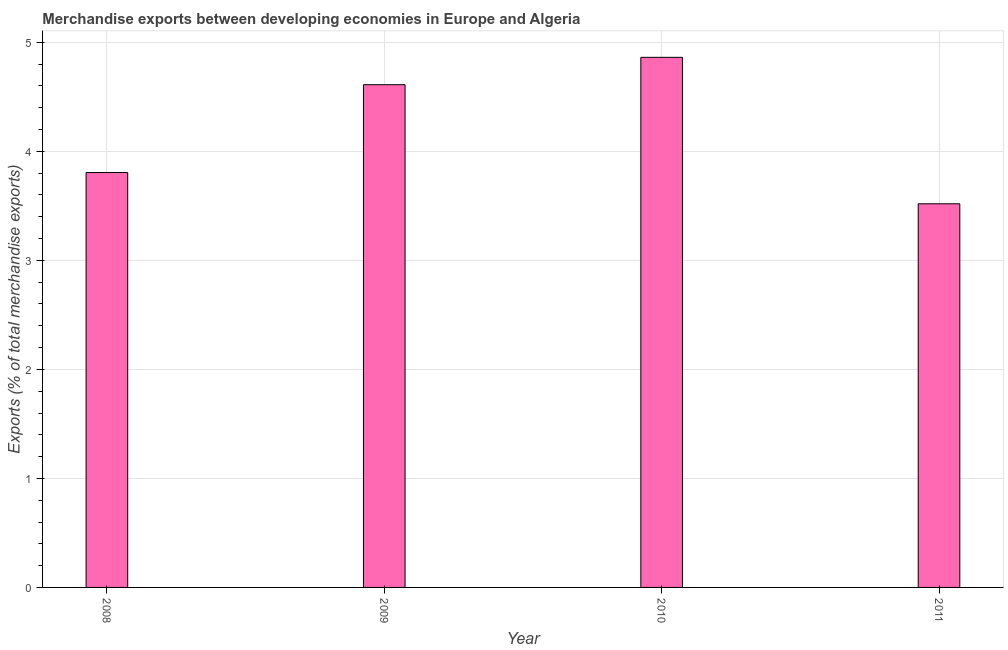What is the title of the graph?
Provide a short and direct response. Merchandise exports between developing economies in Europe and Algeria. What is the label or title of the X-axis?
Keep it short and to the point. Year. What is the label or title of the Y-axis?
Offer a terse response. Exports (% of total merchandise exports). What is the merchandise exports in 2011?
Your answer should be very brief. 3.52. Across all years, what is the maximum merchandise exports?
Offer a very short reply. 4.86. Across all years, what is the minimum merchandise exports?
Give a very brief answer. 3.52. In which year was the merchandise exports maximum?
Your answer should be compact. 2010. In which year was the merchandise exports minimum?
Your response must be concise. 2011. What is the sum of the merchandise exports?
Make the answer very short. 16.8. What is the difference between the merchandise exports in 2010 and 2011?
Offer a terse response. 1.34. What is the median merchandise exports?
Your answer should be very brief. 4.21. Do a majority of the years between 2008 and 2011 (inclusive) have merchandise exports greater than 0.6 %?
Give a very brief answer. Yes. What is the ratio of the merchandise exports in 2008 to that in 2009?
Ensure brevity in your answer.  0.82. Is the merchandise exports in 2008 less than that in 2011?
Offer a terse response. No. Is the difference between the merchandise exports in 2009 and 2011 greater than the difference between any two years?
Give a very brief answer. No. What is the difference between the highest and the second highest merchandise exports?
Your answer should be very brief. 0.25. What is the difference between the highest and the lowest merchandise exports?
Your response must be concise. 1.34. In how many years, is the merchandise exports greater than the average merchandise exports taken over all years?
Your answer should be very brief. 2. How many years are there in the graph?
Give a very brief answer. 4. What is the difference between two consecutive major ticks on the Y-axis?
Offer a terse response. 1. What is the Exports (% of total merchandise exports) in 2008?
Ensure brevity in your answer.  3.81. What is the Exports (% of total merchandise exports) of 2009?
Your response must be concise. 4.61. What is the Exports (% of total merchandise exports) of 2010?
Make the answer very short. 4.86. What is the Exports (% of total merchandise exports) in 2011?
Provide a succinct answer. 3.52. What is the difference between the Exports (% of total merchandise exports) in 2008 and 2009?
Offer a terse response. -0.81. What is the difference between the Exports (% of total merchandise exports) in 2008 and 2010?
Offer a very short reply. -1.06. What is the difference between the Exports (% of total merchandise exports) in 2008 and 2011?
Make the answer very short. 0.29. What is the difference between the Exports (% of total merchandise exports) in 2009 and 2010?
Give a very brief answer. -0.25. What is the difference between the Exports (% of total merchandise exports) in 2009 and 2011?
Your answer should be compact. 1.09. What is the difference between the Exports (% of total merchandise exports) in 2010 and 2011?
Provide a short and direct response. 1.34. What is the ratio of the Exports (% of total merchandise exports) in 2008 to that in 2009?
Ensure brevity in your answer.  0.82. What is the ratio of the Exports (% of total merchandise exports) in 2008 to that in 2010?
Make the answer very short. 0.78. What is the ratio of the Exports (% of total merchandise exports) in 2008 to that in 2011?
Keep it short and to the point. 1.08. What is the ratio of the Exports (% of total merchandise exports) in 2009 to that in 2010?
Make the answer very short. 0.95. What is the ratio of the Exports (% of total merchandise exports) in 2009 to that in 2011?
Keep it short and to the point. 1.31. What is the ratio of the Exports (% of total merchandise exports) in 2010 to that in 2011?
Make the answer very short. 1.38. 